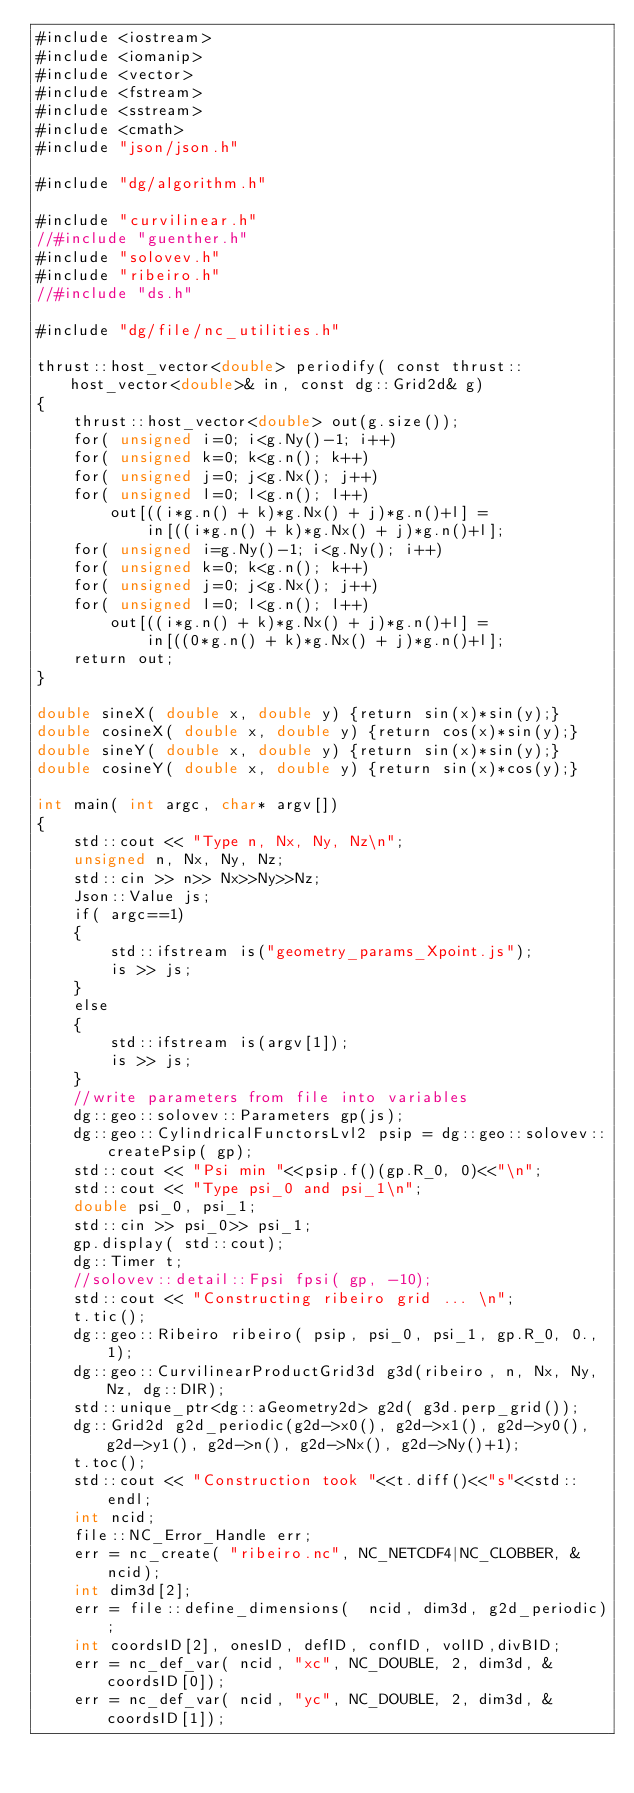Convert code to text. <code><loc_0><loc_0><loc_500><loc_500><_Cuda_>#include <iostream>
#include <iomanip>
#include <vector>
#include <fstream>
#include <sstream>
#include <cmath>
#include "json/json.h"

#include "dg/algorithm.h"

#include "curvilinear.h"
//#include "guenther.h"
#include "solovev.h"
#include "ribeiro.h"
//#include "ds.h"

#include "dg/file/nc_utilities.h"

thrust::host_vector<double> periodify( const thrust::host_vector<double>& in, const dg::Grid2d& g)
{
    thrust::host_vector<double> out(g.size());
    for( unsigned i=0; i<g.Ny()-1; i++)
    for( unsigned k=0; k<g.n(); k++)
    for( unsigned j=0; j<g.Nx(); j++)
    for( unsigned l=0; l<g.n(); l++)
        out[((i*g.n() + k)*g.Nx() + j)*g.n()+l] =
            in[((i*g.n() + k)*g.Nx() + j)*g.n()+l];
    for( unsigned i=g.Ny()-1; i<g.Ny(); i++)
    for( unsigned k=0; k<g.n(); k++)
    for( unsigned j=0; j<g.Nx(); j++)
    for( unsigned l=0; l<g.n(); l++)
        out[((i*g.n() + k)*g.Nx() + j)*g.n()+l] =
            in[((0*g.n() + k)*g.Nx() + j)*g.n()+l];
    return out;
}

double sineX( double x, double y) {return sin(x)*sin(y);}
double cosineX( double x, double y) {return cos(x)*sin(y);}
double sineY( double x, double y) {return sin(x)*sin(y);}
double cosineY( double x, double y) {return sin(x)*cos(y);}

int main( int argc, char* argv[])
{
    std::cout << "Type n, Nx, Ny, Nz\n";
    unsigned n, Nx, Ny, Nz;
    std::cin >> n>> Nx>>Ny>>Nz;
    Json::Value js;
    if( argc==1)
    {
        std::ifstream is("geometry_params_Xpoint.js");
        is >> js;
    }
    else
    {
        std::ifstream is(argv[1]);
        is >> js;
    }
    //write parameters from file into variables
    dg::geo::solovev::Parameters gp(js);
    dg::geo::CylindricalFunctorsLvl2 psip = dg::geo::solovev::createPsip( gp);
    std::cout << "Psi min "<<psip.f()(gp.R_0, 0)<<"\n";
    std::cout << "Type psi_0 and psi_1\n";
    double psi_0, psi_1;
    std::cin >> psi_0>> psi_1;
    gp.display( std::cout);
    dg::Timer t;
    //solovev::detail::Fpsi fpsi( gp, -10);
    std::cout << "Constructing ribeiro grid ... \n";
    t.tic();
    dg::geo::Ribeiro ribeiro( psip, psi_0, psi_1, gp.R_0, 0., 1);
    dg::geo::CurvilinearProductGrid3d g3d(ribeiro, n, Nx, Ny,Nz, dg::DIR);
    std::unique_ptr<dg::aGeometry2d> g2d( g3d.perp_grid());
    dg::Grid2d g2d_periodic(g2d->x0(), g2d->x1(), g2d->y0(), g2d->y1(), g2d->n(), g2d->Nx(), g2d->Ny()+1);
    t.toc();
    std::cout << "Construction took "<<t.diff()<<"s"<<std::endl;
    int ncid;
    file::NC_Error_Handle err;
    err = nc_create( "ribeiro.nc", NC_NETCDF4|NC_CLOBBER, &ncid);
    int dim3d[2];
    err = file::define_dimensions(  ncid, dim3d, g2d_periodic);
    int coordsID[2], onesID, defID, confID, volID,divBID;
    err = nc_def_var( ncid, "xc", NC_DOUBLE, 2, dim3d, &coordsID[0]);
    err = nc_def_var( ncid, "yc", NC_DOUBLE, 2, dim3d, &coordsID[1]);</code> 